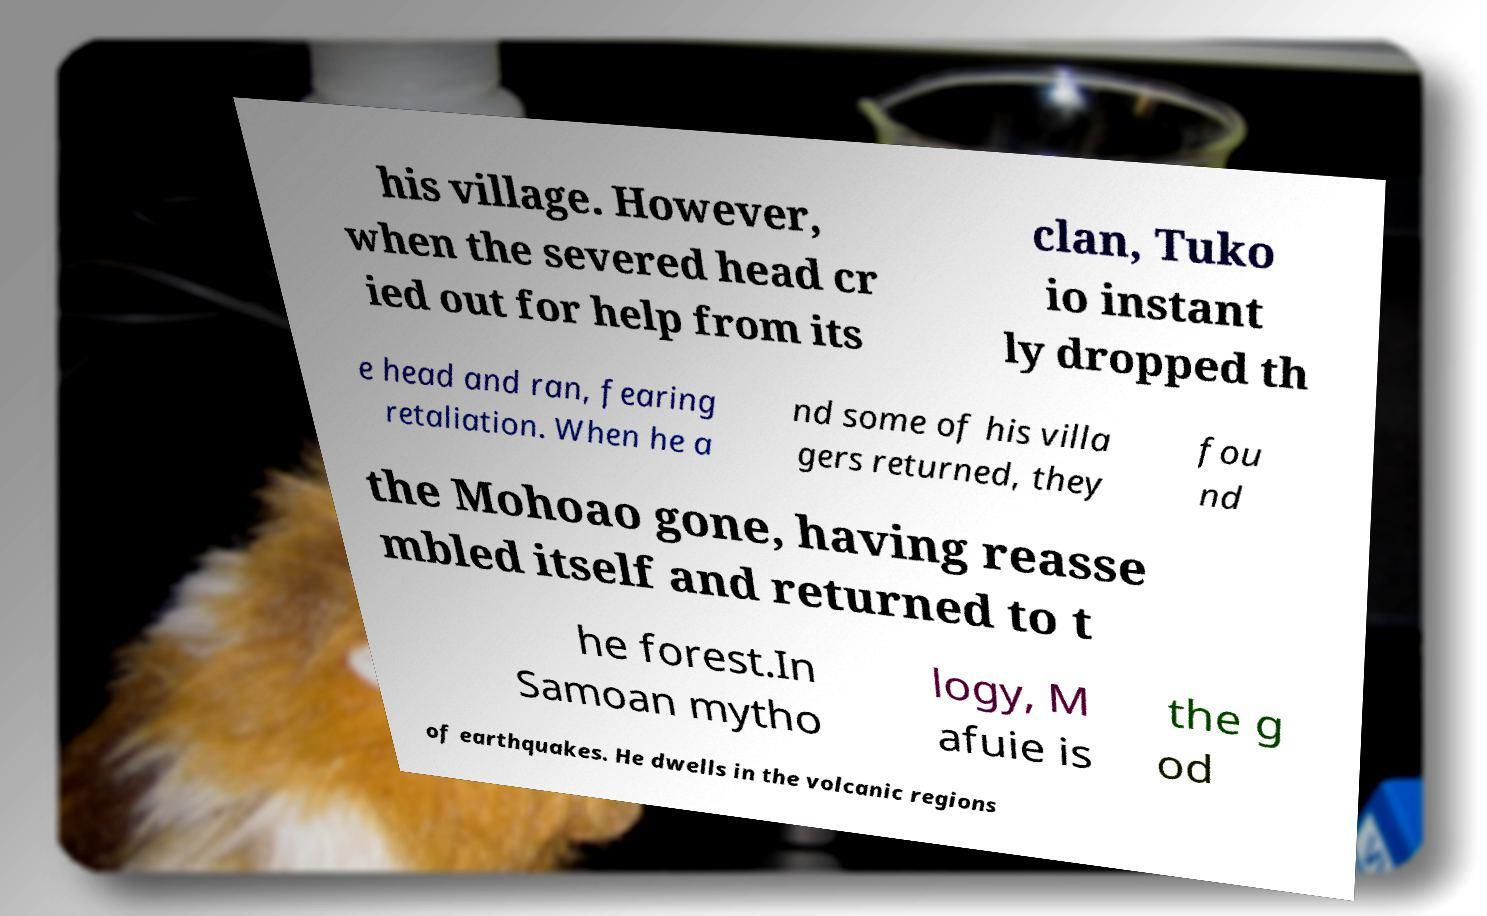For documentation purposes, I need the text within this image transcribed. Could you provide that? his village. However, when the severed head cr ied out for help from its clan, Tuko io instant ly dropped th e head and ran, fearing retaliation. When he a nd some of his villa gers returned, they fou nd the Mohoao gone, having reasse mbled itself and returned to t he forest.In Samoan mytho logy, M afuie is the g od of earthquakes. He dwells in the volcanic regions 